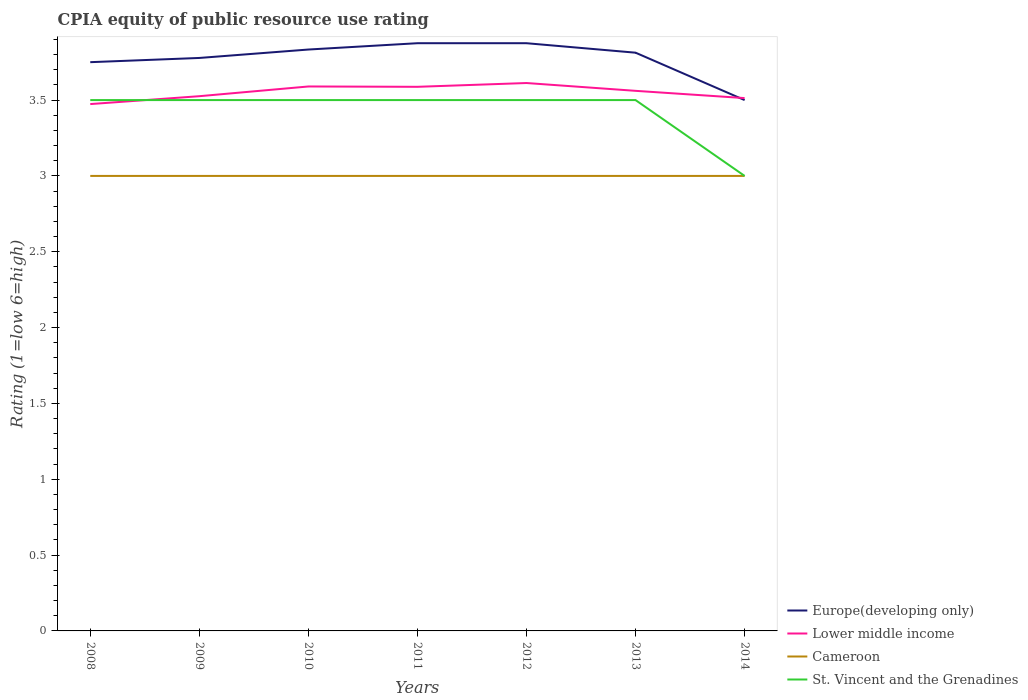How many different coloured lines are there?
Provide a short and direct response. 4. Does the line corresponding to Lower middle income intersect with the line corresponding to Cameroon?
Offer a very short reply. No. Across all years, what is the maximum CPIA rating in Lower middle income?
Your response must be concise. 3.47. In which year was the CPIA rating in Cameroon maximum?
Provide a succinct answer. 2008. What is the total CPIA rating in Lower middle income in the graph?
Your answer should be compact. 0.1. What is the difference between the highest and the second highest CPIA rating in St. Vincent and the Grenadines?
Provide a short and direct response. 0.5. What is the difference between the highest and the lowest CPIA rating in St. Vincent and the Grenadines?
Ensure brevity in your answer.  6. Is the CPIA rating in St. Vincent and the Grenadines strictly greater than the CPIA rating in Lower middle income over the years?
Give a very brief answer. No. How many lines are there?
Make the answer very short. 4. How many years are there in the graph?
Offer a very short reply. 7. What is the difference between two consecutive major ticks on the Y-axis?
Ensure brevity in your answer.  0.5. Are the values on the major ticks of Y-axis written in scientific E-notation?
Give a very brief answer. No. Does the graph contain grids?
Give a very brief answer. No. Where does the legend appear in the graph?
Your answer should be very brief. Bottom right. How many legend labels are there?
Provide a succinct answer. 4. What is the title of the graph?
Offer a terse response. CPIA equity of public resource use rating. Does "Aruba" appear as one of the legend labels in the graph?
Give a very brief answer. No. What is the label or title of the X-axis?
Ensure brevity in your answer.  Years. What is the label or title of the Y-axis?
Your answer should be very brief. Rating (1=low 6=high). What is the Rating (1=low 6=high) in Europe(developing only) in 2008?
Your answer should be compact. 3.75. What is the Rating (1=low 6=high) of Lower middle income in 2008?
Ensure brevity in your answer.  3.47. What is the Rating (1=low 6=high) in Cameroon in 2008?
Keep it short and to the point. 3. What is the Rating (1=low 6=high) in Europe(developing only) in 2009?
Offer a very short reply. 3.78. What is the Rating (1=low 6=high) in Lower middle income in 2009?
Give a very brief answer. 3.53. What is the Rating (1=low 6=high) of Europe(developing only) in 2010?
Keep it short and to the point. 3.83. What is the Rating (1=low 6=high) in Lower middle income in 2010?
Keep it short and to the point. 3.59. What is the Rating (1=low 6=high) of St. Vincent and the Grenadines in 2010?
Offer a very short reply. 3.5. What is the Rating (1=low 6=high) in Europe(developing only) in 2011?
Offer a very short reply. 3.88. What is the Rating (1=low 6=high) in Lower middle income in 2011?
Offer a terse response. 3.59. What is the Rating (1=low 6=high) in Cameroon in 2011?
Offer a very short reply. 3. What is the Rating (1=low 6=high) in Europe(developing only) in 2012?
Give a very brief answer. 3.88. What is the Rating (1=low 6=high) of Lower middle income in 2012?
Provide a short and direct response. 3.61. What is the Rating (1=low 6=high) in Cameroon in 2012?
Keep it short and to the point. 3. What is the Rating (1=low 6=high) in St. Vincent and the Grenadines in 2012?
Provide a succinct answer. 3.5. What is the Rating (1=low 6=high) in Europe(developing only) in 2013?
Keep it short and to the point. 3.81. What is the Rating (1=low 6=high) in Lower middle income in 2013?
Provide a short and direct response. 3.56. What is the Rating (1=low 6=high) of Cameroon in 2013?
Provide a short and direct response. 3. What is the Rating (1=low 6=high) in Lower middle income in 2014?
Ensure brevity in your answer.  3.51. What is the Rating (1=low 6=high) in Cameroon in 2014?
Provide a short and direct response. 3. Across all years, what is the maximum Rating (1=low 6=high) in Europe(developing only)?
Your response must be concise. 3.88. Across all years, what is the maximum Rating (1=low 6=high) in Lower middle income?
Offer a very short reply. 3.61. Across all years, what is the minimum Rating (1=low 6=high) of Lower middle income?
Your answer should be very brief. 3.47. Across all years, what is the minimum Rating (1=low 6=high) in Cameroon?
Ensure brevity in your answer.  3. Across all years, what is the minimum Rating (1=low 6=high) in St. Vincent and the Grenadines?
Offer a terse response. 3. What is the total Rating (1=low 6=high) of Europe(developing only) in the graph?
Make the answer very short. 26.42. What is the total Rating (1=low 6=high) of Lower middle income in the graph?
Keep it short and to the point. 24.86. What is the total Rating (1=low 6=high) of St. Vincent and the Grenadines in the graph?
Give a very brief answer. 24. What is the difference between the Rating (1=low 6=high) of Europe(developing only) in 2008 and that in 2009?
Your answer should be very brief. -0.03. What is the difference between the Rating (1=low 6=high) of Lower middle income in 2008 and that in 2009?
Your response must be concise. -0.05. What is the difference between the Rating (1=low 6=high) of St. Vincent and the Grenadines in 2008 and that in 2009?
Ensure brevity in your answer.  0. What is the difference between the Rating (1=low 6=high) in Europe(developing only) in 2008 and that in 2010?
Your response must be concise. -0.08. What is the difference between the Rating (1=low 6=high) in Lower middle income in 2008 and that in 2010?
Make the answer very short. -0.12. What is the difference between the Rating (1=low 6=high) in Cameroon in 2008 and that in 2010?
Your answer should be compact. 0. What is the difference between the Rating (1=low 6=high) of Europe(developing only) in 2008 and that in 2011?
Keep it short and to the point. -0.12. What is the difference between the Rating (1=low 6=high) in Lower middle income in 2008 and that in 2011?
Your response must be concise. -0.11. What is the difference between the Rating (1=low 6=high) of Cameroon in 2008 and that in 2011?
Ensure brevity in your answer.  0. What is the difference between the Rating (1=low 6=high) of Europe(developing only) in 2008 and that in 2012?
Give a very brief answer. -0.12. What is the difference between the Rating (1=low 6=high) in Lower middle income in 2008 and that in 2012?
Your answer should be compact. -0.14. What is the difference between the Rating (1=low 6=high) of Europe(developing only) in 2008 and that in 2013?
Make the answer very short. -0.06. What is the difference between the Rating (1=low 6=high) in Lower middle income in 2008 and that in 2013?
Your answer should be very brief. -0.09. What is the difference between the Rating (1=low 6=high) of St. Vincent and the Grenadines in 2008 and that in 2013?
Your answer should be very brief. 0. What is the difference between the Rating (1=low 6=high) in Lower middle income in 2008 and that in 2014?
Provide a succinct answer. -0.04. What is the difference between the Rating (1=low 6=high) in Cameroon in 2008 and that in 2014?
Your response must be concise. 0. What is the difference between the Rating (1=low 6=high) in Europe(developing only) in 2009 and that in 2010?
Make the answer very short. -0.06. What is the difference between the Rating (1=low 6=high) in Lower middle income in 2009 and that in 2010?
Keep it short and to the point. -0.06. What is the difference between the Rating (1=low 6=high) in Cameroon in 2009 and that in 2010?
Offer a very short reply. 0. What is the difference between the Rating (1=low 6=high) in Europe(developing only) in 2009 and that in 2011?
Provide a short and direct response. -0.1. What is the difference between the Rating (1=low 6=high) of Lower middle income in 2009 and that in 2011?
Provide a short and direct response. -0.06. What is the difference between the Rating (1=low 6=high) of Cameroon in 2009 and that in 2011?
Provide a short and direct response. 0. What is the difference between the Rating (1=low 6=high) of Europe(developing only) in 2009 and that in 2012?
Your answer should be very brief. -0.1. What is the difference between the Rating (1=low 6=high) in Lower middle income in 2009 and that in 2012?
Your answer should be compact. -0.09. What is the difference between the Rating (1=low 6=high) of Cameroon in 2009 and that in 2012?
Offer a very short reply. 0. What is the difference between the Rating (1=low 6=high) of Europe(developing only) in 2009 and that in 2013?
Make the answer very short. -0.03. What is the difference between the Rating (1=low 6=high) in Lower middle income in 2009 and that in 2013?
Offer a very short reply. -0.04. What is the difference between the Rating (1=low 6=high) in Europe(developing only) in 2009 and that in 2014?
Your response must be concise. 0.28. What is the difference between the Rating (1=low 6=high) of Lower middle income in 2009 and that in 2014?
Provide a short and direct response. 0.01. What is the difference between the Rating (1=low 6=high) in Cameroon in 2009 and that in 2014?
Offer a very short reply. 0. What is the difference between the Rating (1=low 6=high) of St. Vincent and the Grenadines in 2009 and that in 2014?
Offer a terse response. 0.5. What is the difference between the Rating (1=low 6=high) of Europe(developing only) in 2010 and that in 2011?
Make the answer very short. -0.04. What is the difference between the Rating (1=low 6=high) in Lower middle income in 2010 and that in 2011?
Provide a short and direct response. 0. What is the difference between the Rating (1=low 6=high) in Cameroon in 2010 and that in 2011?
Your answer should be very brief. 0. What is the difference between the Rating (1=low 6=high) of Europe(developing only) in 2010 and that in 2012?
Your response must be concise. -0.04. What is the difference between the Rating (1=low 6=high) in Lower middle income in 2010 and that in 2012?
Offer a very short reply. -0.02. What is the difference between the Rating (1=low 6=high) of Europe(developing only) in 2010 and that in 2013?
Ensure brevity in your answer.  0.02. What is the difference between the Rating (1=low 6=high) of Lower middle income in 2010 and that in 2013?
Your response must be concise. 0.03. What is the difference between the Rating (1=low 6=high) of St. Vincent and the Grenadines in 2010 and that in 2013?
Provide a short and direct response. 0. What is the difference between the Rating (1=low 6=high) of Europe(developing only) in 2010 and that in 2014?
Your response must be concise. 0.33. What is the difference between the Rating (1=low 6=high) in Lower middle income in 2010 and that in 2014?
Your response must be concise. 0.08. What is the difference between the Rating (1=low 6=high) in Cameroon in 2010 and that in 2014?
Ensure brevity in your answer.  0. What is the difference between the Rating (1=low 6=high) of Europe(developing only) in 2011 and that in 2012?
Your response must be concise. 0. What is the difference between the Rating (1=low 6=high) in Lower middle income in 2011 and that in 2012?
Your answer should be very brief. -0.03. What is the difference between the Rating (1=low 6=high) of Cameroon in 2011 and that in 2012?
Provide a short and direct response. 0. What is the difference between the Rating (1=low 6=high) of Europe(developing only) in 2011 and that in 2013?
Provide a short and direct response. 0.06. What is the difference between the Rating (1=low 6=high) of Lower middle income in 2011 and that in 2013?
Keep it short and to the point. 0.03. What is the difference between the Rating (1=low 6=high) of Cameroon in 2011 and that in 2013?
Your answer should be compact. 0. What is the difference between the Rating (1=low 6=high) in Europe(developing only) in 2011 and that in 2014?
Your response must be concise. 0.38. What is the difference between the Rating (1=low 6=high) of Lower middle income in 2011 and that in 2014?
Keep it short and to the point. 0.07. What is the difference between the Rating (1=low 6=high) of Cameroon in 2011 and that in 2014?
Offer a terse response. 0. What is the difference between the Rating (1=low 6=high) of St. Vincent and the Grenadines in 2011 and that in 2014?
Your response must be concise. 0.5. What is the difference between the Rating (1=low 6=high) in Europe(developing only) in 2012 and that in 2013?
Your answer should be compact. 0.06. What is the difference between the Rating (1=low 6=high) of Lower middle income in 2012 and that in 2013?
Make the answer very short. 0.05. What is the difference between the Rating (1=low 6=high) in Cameroon in 2012 and that in 2013?
Provide a succinct answer. 0. What is the difference between the Rating (1=low 6=high) of St. Vincent and the Grenadines in 2012 and that in 2013?
Ensure brevity in your answer.  0. What is the difference between the Rating (1=low 6=high) in Europe(developing only) in 2012 and that in 2014?
Provide a succinct answer. 0.38. What is the difference between the Rating (1=low 6=high) in Lower middle income in 2012 and that in 2014?
Your response must be concise. 0.1. What is the difference between the Rating (1=low 6=high) of Europe(developing only) in 2013 and that in 2014?
Make the answer very short. 0.31. What is the difference between the Rating (1=low 6=high) in Lower middle income in 2013 and that in 2014?
Give a very brief answer. 0.05. What is the difference between the Rating (1=low 6=high) in St. Vincent and the Grenadines in 2013 and that in 2014?
Offer a terse response. 0.5. What is the difference between the Rating (1=low 6=high) of Europe(developing only) in 2008 and the Rating (1=low 6=high) of Lower middle income in 2009?
Offer a terse response. 0.22. What is the difference between the Rating (1=low 6=high) of Europe(developing only) in 2008 and the Rating (1=low 6=high) of St. Vincent and the Grenadines in 2009?
Give a very brief answer. 0.25. What is the difference between the Rating (1=low 6=high) in Lower middle income in 2008 and the Rating (1=low 6=high) in Cameroon in 2009?
Your answer should be compact. 0.47. What is the difference between the Rating (1=low 6=high) of Lower middle income in 2008 and the Rating (1=low 6=high) of St. Vincent and the Grenadines in 2009?
Give a very brief answer. -0.03. What is the difference between the Rating (1=low 6=high) in Europe(developing only) in 2008 and the Rating (1=low 6=high) in Lower middle income in 2010?
Make the answer very short. 0.16. What is the difference between the Rating (1=low 6=high) in Lower middle income in 2008 and the Rating (1=low 6=high) in Cameroon in 2010?
Provide a succinct answer. 0.47. What is the difference between the Rating (1=low 6=high) of Lower middle income in 2008 and the Rating (1=low 6=high) of St. Vincent and the Grenadines in 2010?
Your answer should be very brief. -0.03. What is the difference between the Rating (1=low 6=high) of Europe(developing only) in 2008 and the Rating (1=low 6=high) of Lower middle income in 2011?
Your answer should be very brief. 0.16. What is the difference between the Rating (1=low 6=high) in Lower middle income in 2008 and the Rating (1=low 6=high) in Cameroon in 2011?
Ensure brevity in your answer.  0.47. What is the difference between the Rating (1=low 6=high) in Lower middle income in 2008 and the Rating (1=low 6=high) in St. Vincent and the Grenadines in 2011?
Your answer should be very brief. -0.03. What is the difference between the Rating (1=low 6=high) in Europe(developing only) in 2008 and the Rating (1=low 6=high) in Lower middle income in 2012?
Give a very brief answer. 0.14. What is the difference between the Rating (1=low 6=high) of Europe(developing only) in 2008 and the Rating (1=low 6=high) of Cameroon in 2012?
Offer a terse response. 0.75. What is the difference between the Rating (1=low 6=high) in Lower middle income in 2008 and the Rating (1=low 6=high) in Cameroon in 2012?
Ensure brevity in your answer.  0.47. What is the difference between the Rating (1=low 6=high) of Lower middle income in 2008 and the Rating (1=low 6=high) of St. Vincent and the Grenadines in 2012?
Your answer should be very brief. -0.03. What is the difference between the Rating (1=low 6=high) of Europe(developing only) in 2008 and the Rating (1=low 6=high) of Lower middle income in 2013?
Provide a succinct answer. 0.19. What is the difference between the Rating (1=low 6=high) in Lower middle income in 2008 and the Rating (1=low 6=high) in Cameroon in 2013?
Offer a very short reply. 0.47. What is the difference between the Rating (1=low 6=high) in Lower middle income in 2008 and the Rating (1=low 6=high) in St. Vincent and the Grenadines in 2013?
Make the answer very short. -0.03. What is the difference between the Rating (1=low 6=high) in Cameroon in 2008 and the Rating (1=low 6=high) in St. Vincent and the Grenadines in 2013?
Your answer should be compact. -0.5. What is the difference between the Rating (1=low 6=high) in Europe(developing only) in 2008 and the Rating (1=low 6=high) in Lower middle income in 2014?
Offer a terse response. 0.24. What is the difference between the Rating (1=low 6=high) in Europe(developing only) in 2008 and the Rating (1=low 6=high) in Cameroon in 2014?
Offer a very short reply. 0.75. What is the difference between the Rating (1=low 6=high) of Europe(developing only) in 2008 and the Rating (1=low 6=high) of St. Vincent and the Grenadines in 2014?
Give a very brief answer. 0.75. What is the difference between the Rating (1=low 6=high) of Lower middle income in 2008 and the Rating (1=low 6=high) of Cameroon in 2014?
Provide a short and direct response. 0.47. What is the difference between the Rating (1=low 6=high) in Lower middle income in 2008 and the Rating (1=low 6=high) in St. Vincent and the Grenadines in 2014?
Give a very brief answer. 0.47. What is the difference between the Rating (1=low 6=high) in Cameroon in 2008 and the Rating (1=low 6=high) in St. Vincent and the Grenadines in 2014?
Provide a short and direct response. 0. What is the difference between the Rating (1=low 6=high) of Europe(developing only) in 2009 and the Rating (1=low 6=high) of Lower middle income in 2010?
Offer a terse response. 0.19. What is the difference between the Rating (1=low 6=high) in Europe(developing only) in 2009 and the Rating (1=low 6=high) in St. Vincent and the Grenadines in 2010?
Offer a very short reply. 0.28. What is the difference between the Rating (1=low 6=high) of Lower middle income in 2009 and the Rating (1=low 6=high) of Cameroon in 2010?
Your response must be concise. 0.53. What is the difference between the Rating (1=low 6=high) in Lower middle income in 2009 and the Rating (1=low 6=high) in St. Vincent and the Grenadines in 2010?
Offer a terse response. 0.03. What is the difference between the Rating (1=low 6=high) of Cameroon in 2009 and the Rating (1=low 6=high) of St. Vincent and the Grenadines in 2010?
Make the answer very short. -0.5. What is the difference between the Rating (1=low 6=high) in Europe(developing only) in 2009 and the Rating (1=low 6=high) in Lower middle income in 2011?
Your answer should be very brief. 0.19. What is the difference between the Rating (1=low 6=high) in Europe(developing only) in 2009 and the Rating (1=low 6=high) in Cameroon in 2011?
Ensure brevity in your answer.  0.78. What is the difference between the Rating (1=low 6=high) in Europe(developing only) in 2009 and the Rating (1=low 6=high) in St. Vincent and the Grenadines in 2011?
Your answer should be compact. 0.28. What is the difference between the Rating (1=low 6=high) of Lower middle income in 2009 and the Rating (1=low 6=high) of Cameroon in 2011?
Give a very brief answer. 0.53. What is the difference between the Rating (1=low 6=high) in Lower middle income in 2009 and the Rating (1=low 6=high) in St. Vincent and the Grenadines in 2011?
Your answer should be very brief. 0.03. What is the difference between the Rating (1=low 6=high) in Europe(developing only) in 2009 and the Rating (1=low 6=high) in Lower middle income in 2012?
Keep it short and to the point. 0.17. What is the difference between the Rating (1=low 6=high) of Europe(developing only) in 2009 and the Rating (1=low 6=high) of Cameroon in 2012?
Give a very brief answer. 0.78. What is the difference between the Rating (1=low 6=high) in Europe(developing only) in 2009 and the Rating (1=low 6=high) in St. Vincent and the Grenadines in 2012?
Offer a very short reply. 0.28. What is the difference between the Rating (1=low 6=high) in Lower middle income in 2009 and the Rating (1=low 6=high) in Cameroon in 2012?
Your response must be concise. 0.53. What is the difference between the Rating (1=low 6=high) of Lower middle income in 2009 and the Rating (1=low 6=high) of St. Vincent and the Grenadines in 2012?
Ensure brevity in your answer.  0.03. What is the difference between the Rating (1=low 6=high) of Europe(developing only) in 2009 and the Rating (1=low 6=high) of Lower middle income in 2013?
Your answer should be very brief. 0.22. What is the difference between the Rating (1=low 6=high) in Europe(developing only) in 2009 and the Rating (1=low 6=high) in Cameroon in 2013?
Your answer should be very brief. 0.78. What is the difference between the Rating (1=low 6=high) of Europe(developing only) in 2009 and the Rating (1=low 6=high) of St. Vincent and the Grenadines in 2013?
Your answer should be compact. 0.28. What is the difference between the Rating (1=low 6=high) of Lower middle income in 2009 and the Rating (1=low 6=high) of Cameroon in 2013?
Ensure brevity in your answer.  0.53. What is the difference between the Rating (1=low 6=high) of Lower middle income in 2009 and the Rating (1=low 6=high) of St. Vincent and the Grenadines in 2013?
Ensure brevity in your answer.  0.03. What is the difference between the Rating (1=low 6=high) of Cameroon in 2009 and the Rating (1=low 6=high) of St. Vincent and the Grenadines in 2013?
Your answer should be very brief. -0.5. What is the difference between the Rating (1=low 6=high) in Europe(developing only) in 2009 and the Rating (1=low 6=high) in Lower middle income in 2014?
Provide a short and direct response. 0.26. What is the difference between the Rating (1=low 6=high) of Lower middle income in 2009 and the Rating (1=low 6=high) of Cameroon in 2014?
Provide a succinct answer. 0.53. What is the difference between the Rating (1=low 6=high) in Lower middle income in 2009 and the Rating (1=low 6=high) in St. Vincent and the Grenadines in 2014?
Provide a succinct answer. 0.53. What is the difference between the Rating (1=low 6=high) of Europe(developing only) in 2010 and the Rating (1=low 6=high) of Lower middle income in 2011?
Ensure brevity in your answer.  0.25. What is the difference between the Rating (1=low 6=high) of Europe(developing only) in 2010 and the Rating (1=low 6=high) of St. Vincent and the Grenadines in 2011?
Give a very brief answer. 0.33. What is the difference between the Rating (1=low 6=high) in Lower middle income in 2010 and the Rating (1=low 6=high) in Cameroon in 2011?
Make the answer very short. 0.59. What is the difference between the Rating (1=low 6=high) of Lower middle income in 2010 and the Rating (1=low 6=high) of St. Vincent and the Grenadines in 2011?
Offer a terse response. 0.09. What is the difference between the Rating (1=low 6=high) of Cameroon in 2010 and the Rating (1=low 6=high) of St. Vincent and the Grenadines in 2011?
Give a very brief answer. -0.5. What is the difference between the Rating (1=low 6=high) in Europe(developing only) in 2010 and the Rating (1=low 6=high) in Lower middle income in 2012?
Offer a terse response. 0.22. What is the difference between the Rating (1=low 6=high) of Europe(developing only) in 2010 and the Rating (1=low 6=high) of St. Vincent and the Grenadines in 2012?
Your response must be concise. 0.33. What is the difference between the Rating (1=low 6=high) in Lower middle income in 2010 and the Rating (1=low 6=high) in Cameroon in 2012?
Give a very brief answer. 0.59. What is the difference between the Rating (1=low 6=high) in Lower middle income in 2010 and the Rating (1=low 6=high) in St. Vincent and the Grenadines in 2012?
Provide a succinct answer. 0.09. What is the difference between the Rating (1=low 6=high) of Europe(developing only) in 2010 and the Rating (1=low 6=high) of Lower middle income in 2013?
Ensure brevity in your answer.  0.27. What is the difference between the Rating (1=low 6=high) of Europe(developing only) in 2010 and the Rating (1=low 6=high) of St. Vincent and the Grenadines in 2013?
Offer a terse response. 0.33. What is the difference between the Rating (1=low 6=high) in Lower middle income in 2010 and the Rating (1=low 6=high) in Cameroon in 2013?
Give a very brief answer. 0.59. What is the difference between the Rating (1=low 6=high) of Lower middle income in 2010 and the Rating (1=low 6=high) of St. Vincent and the Grenadines in 2013?
Your answer should be compact. 0.09. What is the difference between the Rating (1=low 6=high) in Europe(developing only) in 2010 and the Rating (1=low 6=high) in Lower middle income in 2014?
Give a very brief answer. 0.32. What is the difference between the Rating (1=low 6=high) in Europe(developing only) in 2010 and the Rating (1=low 6=high) in Cameroon in 2014?
Provide a short and direct response. 0.83. What is the difference between the Rating (1=low 6=high) in Europe(developing only) in 2010 and the Rating (1=low 6=high) in St. Vincent and the Grenadines in 2014?
Keep it short and to the point. 0.83. What is the difference between the Rating (1=low 6=high) of Lower middle income in 2010 and the Rating (1=low 6=high) of Cameroon in 2014?
Offer a very short reply. 0.59. What is the difference between the Rating (1=low 6=high) of Lower middle income in 2010 and the Rating (1=low 6=high) of St. Vincent and the Grenadines in 2014?
Your response must be concise. 0.59. What is the difference between the Rating (1=low 6=high) in Europe(developing only) in 2011 and the Rating (1=low 6=high) in Lower middle income in 2012?
Ensure brevity in your answer.  0.26. What is the difference between the Rating (1=low 6=high) in Europe(developing only) in 2011 and the Rating (1=low 6=high) in Cameroon in 2012?
Your answer should be compact. 0.88. What is the difference between the Rating (1=low 6=high) in Europe(developing only) in 2011 and the Rating (1=low 6=high) in St. Vincent and the Grenadines in 2012?
Make the answer very short. 0.38. What is the difference between the Rating (1=low 6=high) in Lower middle income in 2011 and the Rating (1=low 6=high) in Cameroon in 2012?
Keep it short and to the point. 0.59. What is the difference between the Rating (1=low 6=high) of Lower middle income in 2011 and the Rating (1=low 6=high) of St. Vincent and the Grenadines in 2012?
Provide a short and direct response. 0.09. What is the difference between the Rating (1=low 6=high) of Cameroon in 2011 and the Rating (1=low 6=high) of St. Vincent and the Grenadines in 2012?
Provide a short and direct response. -0.5. What is the difference between the Rating (1=low 6=high) in Europe(developing only) in 2011 and the Rating (1=low 6=high) in Lower middle income in 2013?
Give a very brief answer. 0.31. What is the difference between the Rating (1=low 6=high) of Europe(developing only) in 2011 and the Rating (1=low 6=high) of Cameroon in 2013?
Make the answer very short. 0.88. What is the difference between the Rating (1=low 6=high) in Lower middle income in 2011 and the Rating (1=low 6=high) in Cameroon in 2013?
Keep it short and to the point. 0.59. What is the difference between the Rating (1=low 6=high) of Lower middle income in 2011 and the Rating (1=low 6=high) of St. Vincent and the Grenadines in 2013?
Provide a short and direct response. 0.09. What is the difference between the Rating (1=low 6=high) in Europe(developing only) in 2011 and the Rating (1=low 6=high) in Lower middle income in 2014?
Ensure brevity in your answer.  0.36. What is the difference between the Rating (1=low 6=high) in Europe(developing only) in 2011 and the Rating (1=low 6=high) in Cameroon in 2014?
Make the answer very short. 0.88. What is the difference between the Rating (1=low 6=high) of Europe(developing only) in 2011 and the Rating (1=low 6=high) of St. Vincent and the Grenadines in 2014?
Your response must be concise. 0.88. What is the difference between the Rating (1=low 6=high) in Lower middle income in 2011 and the Rating (1=low 6=high) in Cameroon in 2014?
Your response must be concise. 0.59. What is the difference between the Rating (1=low 6=high) in Lower middle income in 2011 and the Rating (1=low 6=high) in St. Vincent and the Grenadines in 2014?
Keep it short and to the point. 0.59. What is the difference between the Rating (1=low 6=high) of Cameroon in 2011 and the Rating (1=low 6=high) of St. Vincent and the Grenadines in 2014?
Your answer should be compact. 0. What is the difference between the Rating (1=low 6=high) in Europe(developing only) in 2012 and the Rating (1=low 6=high) in Lower middle income in 2013?
Make the answer very short. 0.31. What is the difference between the Rating (1=low 6=high) in Europe(developing only) in 2012 and the Rating (1=low 6=high) in Cameroon in 2013?
Make the answer very short. 0.88. What is the difference between the Rating (1=low 6=high) in Europe(developing only) in 2012 and the Rating (1=low 6=high) in St. Vincent and the Grenadines in 2013?
Ensure brevity in your answer.  0.38. What is the difference between the Rating (1=low 6=high) in Lower middle income in 2012 and the Rating (1=low 6=high) in Cameroon in 2013?
Keep it short and to the point. 0.61. What is the difference between the Rating (1=low 6=high) in Lower middle income in 2012 and the Rating (1=low 6=high) in St. Vincent and the Grenadines in 2013?
Keep it short and to the point. 0.11. What is the difference between the Rating (1=low 6=high) in Europe(developing only) in 2012 and the Rating (1=low 6=high) in Lower middle income in 2014?
Make the answer very short. 0.36. What is the difference between the Rating (1=low 6=high) in Europe(developing only) in 2012 and the Rating (1=low 6=high) in Cameroon in 2014?
Keep it short and to the point. 0.88. What is the difference between the Rating (1=low 6=high) in Europe(developing only) in 2012 and the Rating (1=low 6=high) in St. Vincent and the Grenadines in 2014?
Offer a terse response. 0.88. What is the difference between the Rating (1=low 6=high) of Lower middle income in 2012 and the Rating (1=low 6=high) of Cameroon in 2014?
Provide a short and direct response. 0.61. What is the difference between the Rating (1=low 6=high) of Lower middle income in 2012 and the Rating (1=low 6=high) of St. Vincent and the Grenadines in 2014?
Your answer should be compact. 0.61. What is the difference between the Rating (1=low 6=high) of Cameroon in 2012 and the Rating (1=low 6=high) of St. Vincent and the Grenadines in 2014?
Ensure brevity in your answer.  0. What is the difference between the Rating (1=low 6=high) of Europe(developing only) in 2013 and the Rating (1=low 6=high) of Lower middle income in 2014?
Your answer should be compact. 0.3. What is the difference between the Rating (1=low 6=high) of Europe(developing only) in 2013 and the Rating (1=low 6=high) of Cameroon in 2014?
Make the answer very short. 0.81. What is the difference between the Rating (1=low 6=high) in Europe(developing only) in 2013 and the Rating (1=low 6=high) in St. Vincent and the Grenadines in 2014?
Ensure brevity in your answer.  0.81. What is the difference between the Rating (1=low 6=high) of Lower middle income in 2013 and the Rating (1=low 6=high) of Cameroon in 2014?
Keep it short and to the point. 0.56. What is the difference between the Rating (1=low 6=high) in Lower middle income in 2013 and the Rating (1=low 6=high) in St. Vincent and the Grenadines in 2014?
Offer a terse response. 0.56. What is the average Rating (1=low 6=high) in Europe(developing only) per year?
Offer a terse response. 3.77. What is the average Rating (1=low 6=high) of Lower middle income per year?
Your answer should be compact. 3.55. What is the average Rating (1=low 6=high) in Cameroon per year?
Provide a succinct answer. 3. What is the average Rating (1=low 6=high) in St. Vincent and the Grenadines per year?
Your answer should be compact. 3.43. In the year 2008, what is the difference between the Rating (1=low 6=high) in Europe(developing only) and Rating (1=low 6=high) in Lower middle income?
Your answer should be compact. 0.28. In the year 2008, what is the difference between the Rating (1=low 6=high) in Europe(developing only) and Rating (1=low 6=high) in St. Vincent and the Grenadines?
Keep it short and to the point. 0.25. In the year 2008, what is the difference between the Rating (1=low 6=high) in Lower middle income and Rating (1=low 6=high) in Cameroon?
Your answer should be very brief. 0.47. In the year 2008, what is the difference between the Rating (1=low 6=high) in Lower middle income and Rating (1=low 6=high) in St. Vincent and the Grenadines?
Your answer should be very brief. -0.03. In the year 2008, what is the difference between the Rating (1=low 6=high) of Cameroon and Rating (1=low 6=high) of St. Vincent and the Grenadines?
Your answer should be very brief. -0.5. In the year 2009, what is the difference between the Rating (1=low 6=high) of Europe(developing only) and Rating (1=low 6=high) of Lower middle income?
Provide a short and direct response. 0.25. In the year 2009, what is the difference between the Rating (1=low 6=high) of Europe(developing only) and Rating (1=low 6=high) of Cameroon?
Offer a terse response. 0.78. In the year 2009, what is the difference between the Rating (1=low 6=high) in Europe(developing only) and Rating (1=low 6=high) in St. Vincent and the Grenadines?
Give a very brief answer. 0.28. In the year 2009, what is the difference between the Rating (1=low 6=high) of Lower middle income and Rating (1=low 6=high) of Cameroon?
Offer a very short reply. 0.53. In the year 2009, what is the difference between the Rating (1=low 6=high) of Lower middle income and Rating (1=low 6=high) of St. Vincent and the Grenadines?
Your answer should be very brief. 0.03. In the year 2010, what is the difference between the Rating (1=low 6=high) in Europe(developing only) and Rating (1=low 6=high) in Lower middle income?
Ensure brevity in your answer.  0.24. In the year 2010, what is the difference between the Rating (1=low 6=high) in Europe(developing only) and Rating (1=low 6=high) in St. Vincent and the Grenadines?
Your answer should be very brief. 0.33. In the year 2010, what is the difference between the Rating (1=low 6=high) in Lower middle income and Rating (1=low 6=high) in Cameroon?
Your response must be concise. 0.59. In the year 2010, what is the difference between the Rating (1=low 6=high) of Lower middle income and Rating (1=low 6=high) of St. Vincent and the Grenadines?
Ensure brevity in your answer.  0.09. In the year 2011, what is the difference between the Rating (1=low 6=high) in Europe(developing only) and Rating (1=low 6=high) in Lower middle income?
Provide a short and direct response. 0.29. In the year 2011, what is the difference between the Rating (1=low 6=high) in Europe(developing only) and Rating (1=low 6=high) in Cameroon?
Make the answer very short. 0.88. In the year 2011, what is the difference between the Rating (1=low 6=high) in Europe(developing only) and Rating (1=low 6=high) in St. Vincent and the Grenadines?
Provide a succinct answer. 0.38. In the year 2011, what is the difference between the Rating (1=low 6=high) of Lower middle income and Rating (1=low 6=high) of Cameroon?
Offer a terse response. 0.59. In the year 2011, what is the difference between the Rating (1=low 6=high) of Lower middle income and Rating (1=low 6=high) of St. Vincent and the Grenadines?
Provide a succinct answer. 0.09. In the year 2011, what is the difference between the Rating (1=low 6=high) in Cameroon and Rating (1=low 6=high) in St. Vincent and the Grenadines?
Ensure brevity in your answer.  -0.5. In the year 2012, what is the difference between the Rating (1=low 6=high) of Europe(developing only) and Rating (1=low 6=high) of Lower middle income?
Your answer should be very brief. 0.26. In the year 2012, what is the difference between the Rating (1=low 6=high) of Europe(developing only) and Rating (1=low 6=high) of Cameroon?
Give a very brief answer. 0.88. In the year 2012, what is the difference between the Rating (1=low 6=high) in Europe(developing only) and Rating (1=low 6=high) in St. Vincent and the Grenadines?
Provide a short and direct response. 0.38. In the year 2012, what is the difference between the Rating (1=low 6=high) of Lower middle income and Rating (1=low 6=high) of Cameroon?
Ensure brevity in your answer.  0.61. In the year 2012, what is the difference between the Rating (1=low 6=high) of Lower middle income and Rating (1=low 6=high) of St. Vincent and the Grenadines?
Offer a very short reply. 0.11. In the year 2012, what is the difference between the Rating (1=low 6=high) of Cameroon and Rating (1=low 6=high) of St. Vincent and the Grenadines?
Give a very brief answer. -0.5. In the year 2013, what is the difference between the Rating (1=low 6=high) of Europe(developing only) and Rating (1=low 6=high) of Lower middle income?
Make the answer very short. 0.25. In the year 2013, what is the difference between the Rating (1=low 6=high) in Europe(developing only) and Rating (1=low 6=high) in Cameroon?
Give a very brief answer. 0.81. In the year 2013, what is the difference between the Rating (1=low 6=high) of Europe(developing only) and Rating (1=low 6=high) of St. Vincent and the Grenadines?
Your answer should be very brief. 0.31. In the year 2013, what is the difference between the Rating (1=low 6=high) of Lower middle income and Rating (1=low 6=high) of Cameroon?
Make the answer very short. 0.56. In the year 2013, what is the difference between the Rating (1=low 6=high) of Lower middle income and Rating (1=low 6=high) of St. Vincent and the Grenadines?
Ensure brevity in your answer.  0.06. In the year 2013, what is the difference between the Rating (1=low 6=high) of Cameroon and Rating (1=low 6=high) of St. Vincent and the Grenadines?
Make the answer very short. -0.5. In the year 2014, what is the difference between the Rating (1=low 6=high) in Europe(developing only) and Rating (1=low 6=high) in Lower middle income?
Ensure brevity in your answer.  -0.01. In the year 2014, what is the difference between the Rating (1=low 6=high) of Europe(developing only) and Rating (1=low 6=high) of Cameroon?
Keep it short and to the point. 0.5. In the year 2014, what is the difference between the Rating (1=low 6=high) in Lower middle income and Rating (1=low 6=high) in Cameroon?
Provide a short and direct response. 0.51. In the year 2014, what is the difference between the Rating (1=low 6=high) of Lower middle income and Rating (1=low 6=high) of St. Vincent and the Grenadines?
Offer a very short reply. 0.51. In the year 2014, what is the difference between the Rating (1=low 6=high) of Cameroon and Rating (1=low 6=high) of St. Vincent and the Grenadines?
Make the answer very short. 0. What is the ratio of the Rating (1=low 6=high) in Lower middle income in 2008 to that in 2009?
Provide a short and direct response. 0.99. What is the ratio of the Rating (1=low 6=high) of Cameroon in 2008 to that in 2009?
Your answer should be compact. 1. What is the ratio of the Rating (1=low 6=high) in St. Vincent and the Grenadines in 2008 to that in 2009?
Make the answer very short. 1. What is the ratio of the Rating (1=low 6=high) of Europe(developing only) in 2008 to that in 2010?
Ensure brevity in your answer.  0.98. What is the ratio of the Rating (1=low 6=high) of Cameroon in 2008 to that in 2010?
Your answer should be very brief. 1. What is the ratio of the Rating (1=low 6=high) of St. Vincent and the Grenadines in 2008 to that in 2010?
Keep it short and to the point. 1. What is the ratio of the Rating (1=low 6=high) of Lower middle income in 2008 to that in 2011?
Provide a succinct answer. 0.97. What is the ratio of the Rating (1=low 6=high) of Lower middle income in 2008 to that in 2012?
Give a very brief answer. 0.96. What is the ratio of the Rating (1=low 6=high) of St. Vincent and the Grenadines in 2008 to that in 2012?
Offer a very short reply. 1. What is the ratio of the Rating (1=low 6=high) of Europe(developing only) in 2008 to that in 2013?
Ensure brevity in your answer.  0.98. What is the ratio of the Rating (1=low 6=high) of Lower middle income in 2008 to that in 2013?
Make the answer very short. 0.98. What is the ratio of the Rating (1=low 6=high) in Cameroon in 2008 to that in 2013?
Offer a very short reply. 1. What is the ratio of the Rating (1=low 6=high) of St. Vincent and the Grenadines in 2008 to that in 2013?
Ensure brevity in your answer.  1. What is the ratio of the Rating (1=low 6=high) in Europe(developing only) in 2008 to that in 2014?
Your response must be concise. 1.07. What is the ratio of the Rating (1=low 6=high) in Lower middle income in 2008 to that in 2014?
Ensure brevity in your answer.  0.99. What is the ratio of the Rating (1=low 6=high) of Europe(developing only) in 2009 to that in 2010?
Make the answer very short. 0.99. What is the ratio of the Rating (1=low 6=high) of Lower middle income in 2009 to that in 2010?
Offer a terse response. 0.98. What is the ratio of the Rating (1=low 6=high) in Europe(developing only) in 2009 to that in 2011?
Your response must be concise. 0.97. What is the ratio of the Rating (1=low 6=high) of Lower middle income in 2009 to that in 2011?
Provide a short and direct response. 0.98. What is the ratio of the Rating (1=low 6=high) of Europe(developing only) in 2009 to that in 2012?
Your answer should be very brief. 0.97. What is the ratio of the Rating (1=low 6=high) of Lower middle income in 2009 to that in 2012?
Give a very brief answer. 0.98. What is the ratio of the Rating (1=low 6=high) of St. Vincent and the Grenadines in 2009 to that in 2012?
Offer a very short reply. 1. What is the ratio of the Rating (1=low 6=high) of Europe(developing only) in 2009 to that in 2013?
Your response must be concise. 0.99. What is the ratio of the Rating (1=low 6=high) of Lower middle income in 2009 to that in 2013?
Ensure brevity in your answer.  0.99. What is the ratio of the Rating (1=low 6=high) of Europe(developing only) in 2009 to that in 2014?
Offer a terse response. 1.08. What is the ratio of the Rating (1=low 6=high) of Europe(developing only) in 2010 to that in 2011?
Give a very brief answer. 0.99. What is the ratio of the Rating (1=low 6=high) of Lower middle income in 2010 to that in 2011?
Your answer should be compact. 1. What is the ratio of the Rating (1=low 6=high) of Cameroon in 2010 to that in 2011?
Offer a very short reply. 1. What is the ratio of the Rating (1=low 6=high) of St. Vincent and the Grenadines in 2010 to that in 2011?
Keep it short and to the point. 1. What is the ratio of the Rating (1=low 6=high) in Europe(developing only) in 2010 to that in 2012?
Your answer should be very brief. 0.99. What is the ratio of the Rating (1=low 6=high) in Lower middle income in 2010 to that in 2012?
Make the answer very short. 0.99. What is the ratio of the Rating (1=low 6=high) in Europe(developing only) in 2010 to that in 2013?
Make the answer very short. 1.01. What is the ratio of the Rating (1=low 6=high) in Lower middle income in 2010 to that in 2013?
Offer a terse response. 1.01. What is the ratio of the Rating (1=low 6=high) of St. Vincent and the Grenadines in 2010 to that in 2013?
Your answer should be very brief. 1. What is the ratio of the Rating (1=low 6=high) in Europe(developing only) in 2010 to that in 2014?
Offer a very short reply. 1.1. What is the ratio of the Rating (1=low 6=high) of Lower middle income in 2010 to that in 2014?
Give a very brief answer. 1.02. What is the ratio of the Rating (1=low 6=high) of Cameroon in 2010 to that in 2014?
Your answer should be very brief. 1. What is the ratio of the Rating (1=low 6=high) in St. Vincent and the Grenadines in 2011 to that in 2012?
Provide a short and direct response. 1. What is the ratio of the Rating (1=low 6=high) of Europe(developing only) in 2011 to that in 2013?
Your response must be concise. 1.02. What is the ratio of the Rating (1=low 6=high) in Lower middle income in 2011 to that in 2013?
Give a very brief answer. 1.01. What is the ratio of the Rating (1=low 6=high) of St. Vincent and the Grenadines in 2011 to that in 2013?
Offer a terse response. 1. What is the ratio of the Rating (1=low 6=high) in Europe(developing only) in 2011 to that in 2014?
Keep it short and to the point. 1.11. What is the ratio of the Rating (1=low 6=high) in Lower middle income in 2011 to that in 2014?
Your answer should be very brief. 1.02. What is the ratio of the Rating (1=low 6=high) in Europe(developing only) in 2012 to that in 2013?
Provide a succinct answer. 1.02. What is the ratio of the Rating (1=low 6=high) of Lower middle income in 2012 to that in 2013?
Your answer should be compact. 1.01. What is the ratio of the Rating (1=low 6=high) of St. Vincent and the Grenadines in 2012 to that in 2013?
Your answer should be compact. 1. What is the ratio of the Rating (1=low 6=high) of Europe(developing only) in 2012 to that in 2014?
Give a very brief answer. 1.11. What is the ratio of the Rating (1=low 6=high) of Lower middle income in 2012 to that in 2014?
Your answer should be very brief. 1.03. What is the ratio of the Rating (1=low 6=high) in Cameroon in 2012 to that in 2014?
Your answer should be very brief. 1. What is the ratio of the Rating (1=low 6=high) of St. Vincent and the Grenadines in 2012 to that in 2014?
Your answer should be compact. 1.17. What is the ratio of the Rating (1=low 6=high) of Europe(developing only) in 2013 to that in 2014?
Your answer should be very brief. 1.09. What is the ratio of the Rating (1=low 6=high) in Lower middle income in 2013 to that in 2014?
Your response must be concise. 1.01. What is the ratio of the Rating (1=low 6=high) in Cameroon in 2013 to that in 2014?
Give a very brief answer. 1. What is the difference between the highest and the second highest Rating (1=low 6=high) in Lower middle income?
Your response must be concise. 0.02. What is the difference between the highest and the second highest Rating (1=low 6=high) in Cameroon?
Provide a succinct answer. 0. What is the difference between the highest and the second highest Rating (1=low 6=high) of St. Vincent and the Grenadines?
Give a very brief answer. 0. What is the difference between the highest and the lowest Rating (1=low 6=high) in Lower middle income?
Your response must be concise. 0.14. What is the difference between the highest and the lowest Rating (1=low 6=high) of St. Vincent and the Grenadines?
Your answer should be compact. 0.5. 